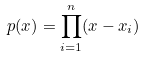<formula> <loc_0><loc_0><loc_500><loc_500>p ( x ) = \prod _ { i = 1 } ^ { n } ( x - x _ { i } )</formula> 